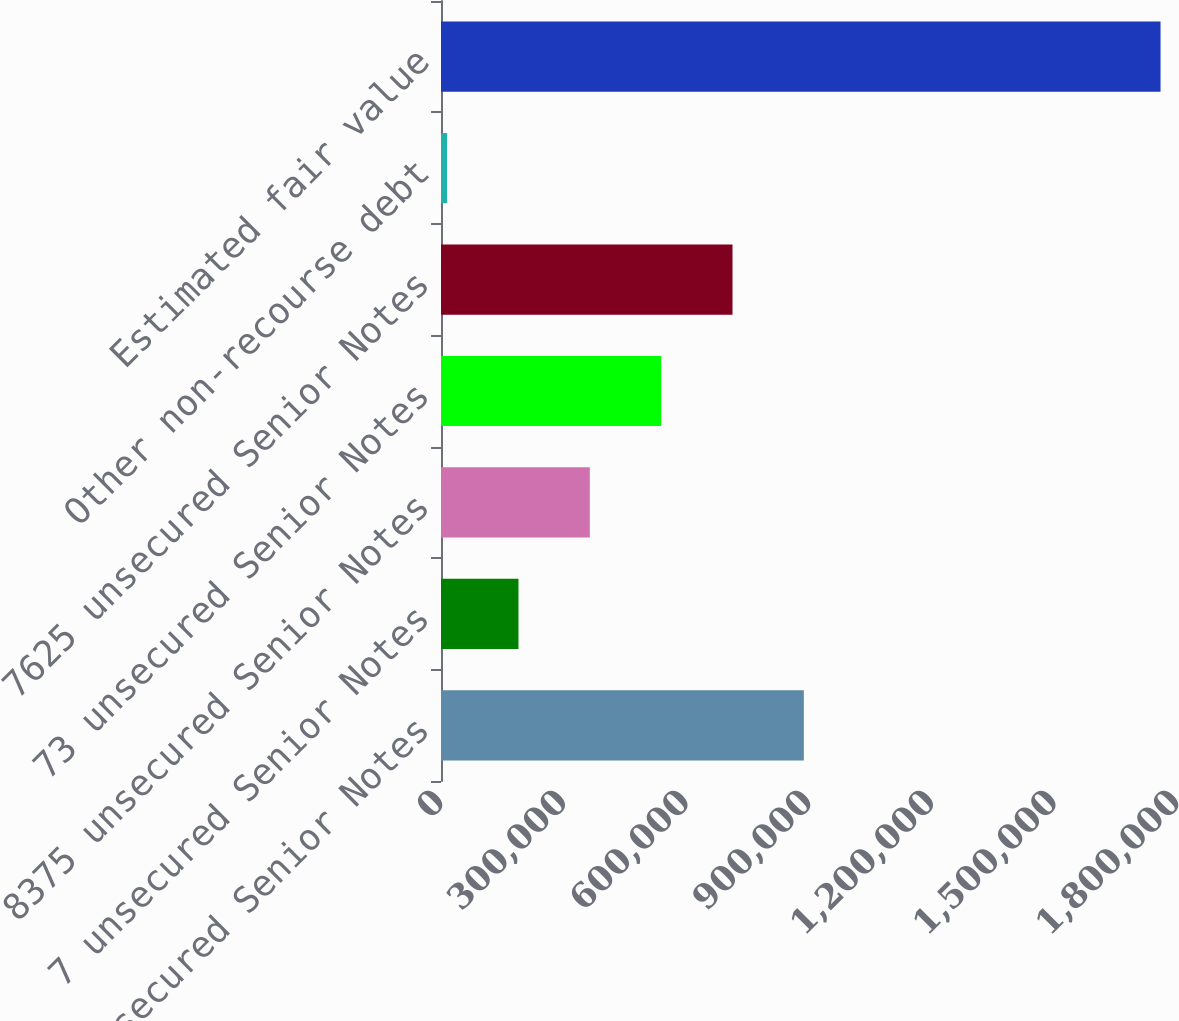<chart> <loc_0><loc_0><loc_500><loc_500><bar_chart><fcel>95 unsecured Senior Notes<fcel>7 unsecured Senior Notes<fcel>8375 unsecured Senior Notes<fcel>73 unsecured Senior Notes<fcel>7625 unsecured Senior Notes<fcel>Other non-recourse debt<fcel>Estimated fair value<nl><fcel>887368<fcel>189478<fcel>363950<fcel>538423<fcel>712895<fcel>15005<fcel>1.75973e+06<nl></chart> 